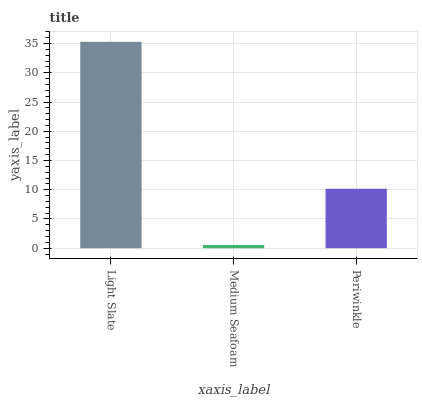Is Medium Seafoam the minimum?
Answer yes or no. Yes. Is Light Slate the maximum?
Answer yes or no. Yes. Is Periwinkle the minimum?
Answer yes or no. No. Is Periwinkle the maximum?
Answer yes or no. No. Is Periwinkle greater than Medium Seafoam?
Answer yes or no. Yes. Is Medium Seafoam less than Periwinkle?
Answer yes or no. Yes. Is Medium Seafoam greater than Periwinkle?
Answer yes or no. No. Is Periwinkle less than Medium Seafoam?
Answer yes or no. No. Is Periwinkle the high median?
Answer yes or no. Yes. Is Periwinkle the low median?
Answer yes or no. Yes. Is Medium Seafoam the high median?
Answer yes or no. No. Is Light Slate the low median?
Answer yes or no. No. 